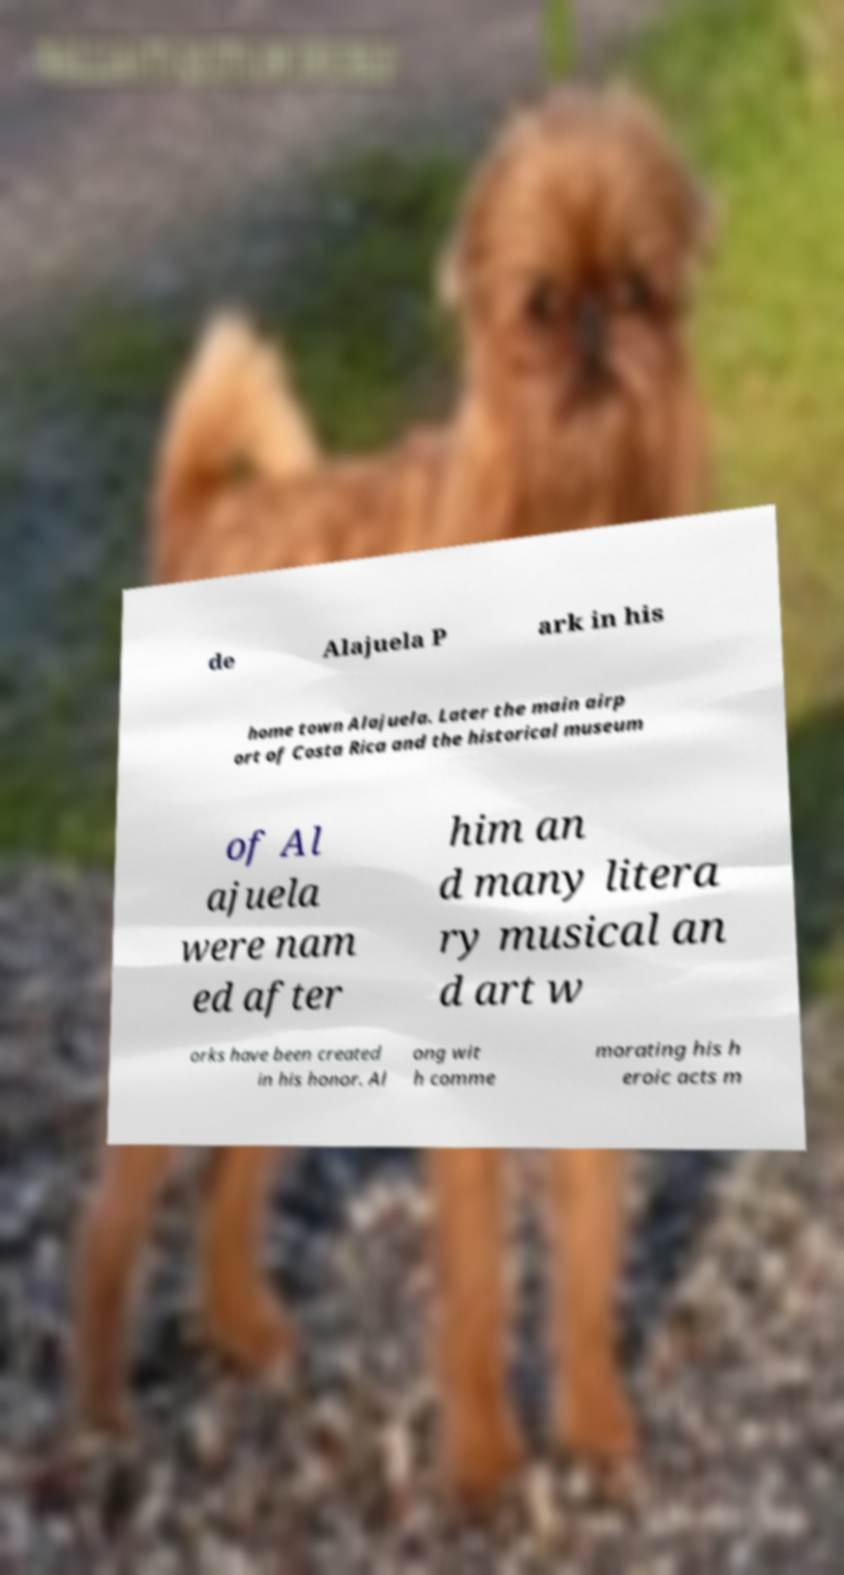For documentation purposes, I need the text within this image transcribed. Could you provide that? de Alajuela P ark in his home town Alajuela. Later the main airp ort of Costa Rica and the historical museum of Al ajuela were nam ed after him an d many litera ry musical an d art w orks have been created in his honor. Al ong wit h comme morating his h eroic acts m 